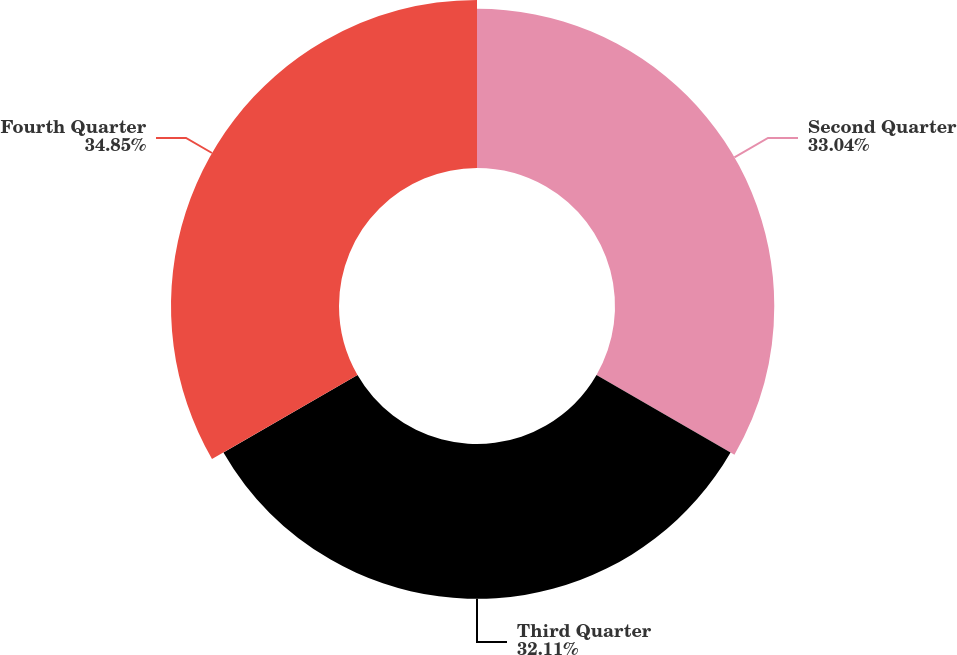Convert chart to OTSL. <chart><loc_0><loc_0><loc_500><loc_500><pie_chart><fcel>Second Quarter<fcel>Third Quarter<fcel>Fourth Quarter<nl><fcel>33.04%<fcel>32.11%<fcel>34.85%<nl></chart> 